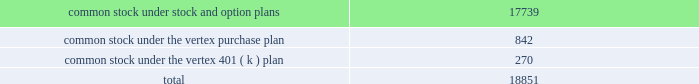"distribution date" ) .
Until the distribution date ( or earlier redemption or expiration of the rights ) , the rights will be traded with , and only with , the common stock .
Until a right is exercised , the right will not entitle the holder thereof to any rights as a stockholder .
If any person or group becomes an acquiring person , each holder of a right , other than rights beneficially owned by the acquiring person , will thereafter have the right to receive upon exercise and payment of the purchase price that number of shares of common stock having a market value of two times the purchase price and , if the company is acquired in a business combination transaction or 50% ( 50 % ) or more of its assets are sold , each holder of a right will thereafter have the right to receive upon exercise and payment of the purchase price that number of shares of common stock of the acquiring company which at the time of the transaction will have a market value of two times the purchase price .
At any time after any person becomes an acquiring person and prior to the acquisition by such person or group of 50% ( 50 % ) or more of the outstanding common stock , the board of directors of the company may cause the rights ( other than rights owned by such person or group ) to be exchanged , in whole or in part , for common stock or junior preferred shares , at an exchange rate of one share of common stock per right or one half of one-hundredth of a junior preferred share per right .
At any time prior to the acquisition by a person or group of beneficial ownership of 15% ( 15 % ) or more of the outstanding common stock , the board of directors of the company may redeem the rights at a price of $ 0.01 per right .
The rights have certain anti-takeover effects , in that they will cause substantial dilution to a person or group that attempts to acquire a significant interest in vertex on terms not approved by the board of directors .
Common stock reserved for future issuance at december 31 , 2005 , the company has reserved shares of common stock for future issuance under all equity compensation plans as follows ( shares in thousands ) : o .
Significant revenue arrangements the company has formed strategic collaborations with pharmaceutical companies and other organizations in the areas of drug discovery , development , and commercialization .
Research , development and commercialization agreements provide the company with financial support and other valuable resources for its research programs and for the development of clinical drug candidates , and the marketing and sales of products .
Collaborative research , development and commercialization agreements in the company's collaborative research , development and commercialization programs the company seeks to discover , develop and commercialize pharmaceutical products in conjunction with and supported by the company's collaborators .
Collaborative research and development arrangements may provide research funding over an initial contract period with renewal and termination options that .

What was the percent of the common stock under the vertex 401 ( k ) plan as part of the total common stock used for research funding? 
Computations: (270 / 18851)
Answer: 0.01432. 